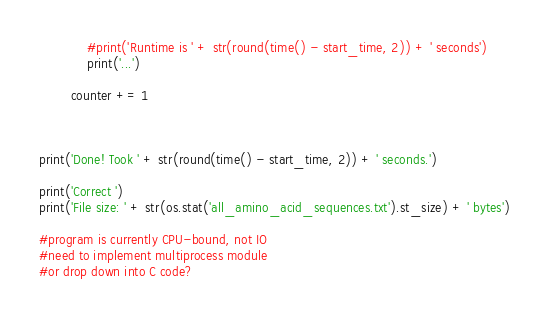<code> <loc_0><loc_0><loc_500><loc_500><_Python_>            #print('Runtime is ' + str(round(time() - start_time, 2)) + ' seconds')
            print('...')

        counter += 1



print('Done! Took ' + str(round(time() - start_time, 2)) + ' seconds.')

print('Correct ')
print('File size: ' + str(os.stat('all_amino_acid_sequences.txt').st_size) + ' bytes')

#program is currently CPU-bound, not IO
#need to implement multiprocess module
#or drop down into C code?
</code> 